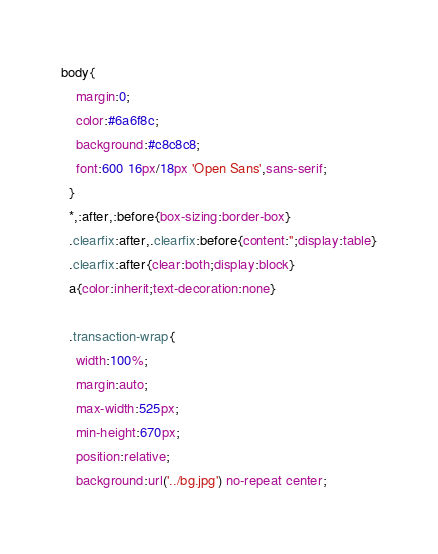Convert code to text. <code><loc_0><loc_0><loc_500><loc_500><_CSS_>body{
    margin:0;
    color:#6a6f8c;
    background:#c8c8c8;
    font:600 16px/18px 'Open Sans',sans-serif;
  }
  *,:after,:before{box-sizing:border-box}
  .clearfix:after,.clearfix:before{content:'';display:table}
  .clearfix:after{clear:both;display:block}
  a{color:inherit;text-decoration:none}
  
  .transaction-wrap{
    width:100%;
    margin:auto;
    max-width:525px;
    min-height:670px;
    position:relative;
    background:url('../bg.jpg') no-repeat center;</code> 